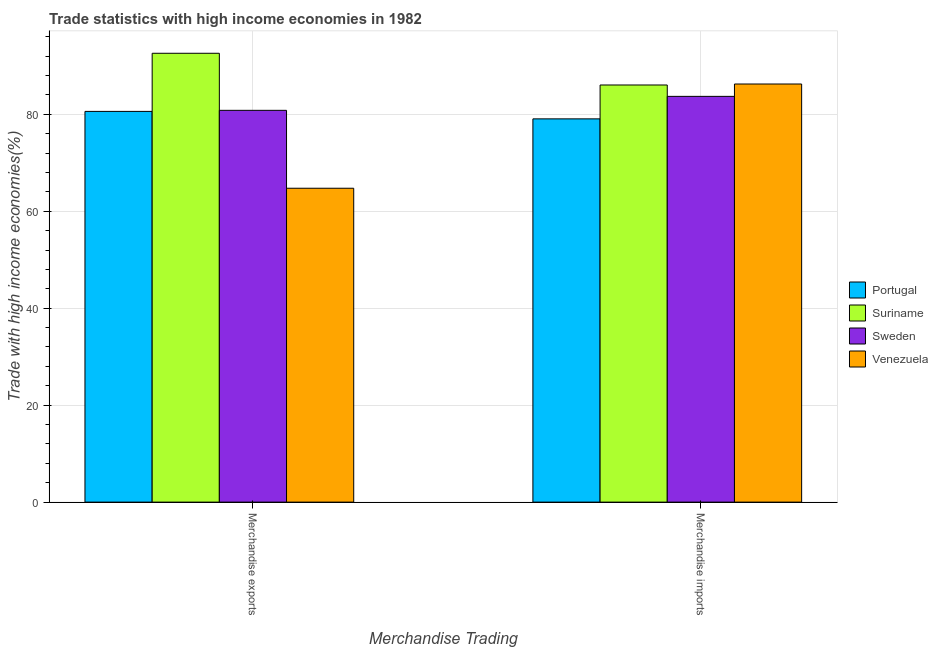How many different coloured bars are there?
Offer a very short reply. 4. How many groups of bars are there?
Keep it short and to the point. 2. How many bars are there on the 1st tick from the left?
Your response must be concise. 4. What is the merchandise imports in Venezuela?
Offer a very short reply. 86.25. Across all countries, what is the maximum merchandise exports?
Your response must be concise. 92.59. Across all countries, what is the minimum merchandise exports?
Your answer should be compact. 64.75. In which country was the merchandise imports maximum?
Your response must be concise. Venezuela. In which country was the merchandise exports minimum?
Keep it short and to the point. Venezuela. What is the total merchandise exports in the graph?
Give a very brief answer. 318.75. What is the difference between the merchandise exports in Portugal and that in Suriname?
Ensure brevity in your answer.  -11.99. What is the difference between the merchandise exports in Venezuela and the merchandise imports in Portugal?
Provide a short and direct response. -14.31. What is the average merchandise imports per country?
Your answer should be very brief. 83.76. What is the difference between the merchandise imports and merchandise exports in Portugal?
Offer a terse response. -1.54. In how many countries, is the merchandise exports greater than 60 %?
Keep it short and to the point. 4. What is the ratio of the merchandise imports in Venezuela to that in Portugal?
Keep it short and to the point. 1.09. In how many countries, is the merchandise imports greater than the average merchandise imports taken over all countries?
Give a very brief answer. 2. What does the 4th bar from the left in Merchandise imports represents?
Offer a terse response. Venezuela. What does the 3rd bar from the right in Merchandise imports represents?
Keep it short and to the point. Suriname. How many bars are there?
Offer a very short reply. 8. How many countries are there in the graph?
Provide a succinct answer. 4. What is the difference between two consecutive major ticks on the Y-axis?
Provide a short and direct response. 20. How many legend labels are there?
Provide a succinct answer. 4. How are the legend labels stacked?
Provide a short and direct response. Vertical. What is the title of the graph?
Give a very brief answer. Trade statistics with high income economies in 1982. What is the label or title of the X-axis?
Provide a succinct answer. Merchandise Trading. What is the label or title of the Y-axis?
Your answer should be very brief. Trade with high income economies(%). What is the Trade with high income economies(%) in Portugal in Merchandise exports?
Your answer should be compact. 80.6. What is the Trade with high income economies(%) of Suriname in Merchandise exports?
Your response must be concise. 92.59. What is the Trade with high income economies(%) of Sweden in Merchandise exports?
Your answer should be very brief. 80.82. What is the Trade with high income economies(%) of Venezuela in Merchandise exports?
Your answer should be very brief. 64.75. What is the Trade with high income economies(%) in Portugal in Merchandise imports?
Offer a very short reply. 79.06. What is the Trade with high income economies(%) in Suriname in Merchandise imports?
Offer a terse response. 86.05. What is the Trade with high income economies(%) of Sweden in Merchandise imports?
Provide a succinct answer. 83.7. What is the Trade with high income economies(%) in Venezuela in Merchandise imports?
Provide a short and direct response. 86.25. Across all Merchandise Trading, what is the maximum Trade with high income economies(%) in Portugal?
Give a very brief answer. 80.6. Across all Merchandise Trading, what is the maximum Trade with high income economies(%) of Suriname?
Give a very brief answer. 92.59. Across all Merchandise Trading, what is the maximum Trade with high income economies(%) of Sweden?
Give a very brief answer. 83.7. Across all Merchandise Trading, what is the maximum Trade with high income economies(%) of Venezuela?
Your response must be concise. 86.25. Across all Merchandise Trading, what is the minimum Trade with high income economies(%) of Portugal?
Provide a short and direct response. 79.06. Across all Merchandise Trading, what is the minimum Trade with high income economies(%) of Suriname?
Give a very brief answer. 86.05. Across all Merchandise Trading, what is the minimum Trade with high income economies(%) in Sweden?
Provide a succinct answer. 80.82. Across all Merchandise Trading, what is the minimum Trade with high income economies(%) in Venezuela?
Provide a succinct answer. 64.75. What is the total Trade with high income economies(%) in Portugal in the graph?
Provide a succinct answer. 159.66. What is the total Trade with high income economies(%) of Suriname in the graph?
Offer a very short reply. 178.64. What is the total Trade with high income economies(%) in Sweden in the graph?
Provide a succinct answer. 164.52. What is the total Trade with high income economies(%) in Venezuela in the graph?
Offer a terse response. 151. What is the difference between the Trade with high income economies(%) in Portugal in Merchandise exports and that in Merchandise imports?
Your response must be concise. 1.54. What is the difference between the Trade with high income economies(%) of Suriname in Merchandise exports and that in Merchandise imports?
Provide a succinct answer. 6.54. What is the difference between the Trade with high income economies(%) of Sweden in Merchandise exports and that in Merchandise imports?
Make the answer very short. -2.88. What is the difference between the Trade with high income economies(%) of Venezuela in Merchandise exports and that in Merchandise imports?
Ensure brevity in your answer.  -21.5. What is the difference between the Trade with high income economies(%) of Portugal in Merchandise exports and the Trade with high income economies(%) of Suriname in Merchandise imports?
Your answer should be very brief. -5.45. What is the difference between the Trade with high income economies(%) in Portugal in Merchandise exports and the Trade with high income economies(%) in Sweden in Merchandise imports?
Offer a terse response. -3.1. What is the difference between the Trade with high income economies(%) of Portugal in Merchandise exports and the Trade with high income economies(%) of Venezuela in Merchandise imports?
Offer a terse response. -5.65. What is the difference between the Trade with high income economies(%) in Suriname in Merchandise exports and the Trade with high income economies(%) in Sweden in Merchandise imports?
Your response must be concise. 8.89. What is the difference between the Trade with high income economies(%) in Suriname in Merchandise exports and the Trade with high income economies(%) in Venezuela in Merchandise imports?
Provide a succinct answer. 6.34. What is the difference between the Trade with high income economies(%) of Sweden in Merchandise exports and the Trade with high income economies(%) of Venezuela in Merchandise imports?
Your response must be concise. -5.43. What is the average Trade with high income economies(%) of Portugal per Merchandise Trading?
Make the answer very short. 79.83. What is the average Trade with high income economies(%) in Suriname per Merchandise Trading?
Offer a terse response. 89.32. What is the average Trade with high income economies(%) of Sweden per Merchandise Trading?
Your answer should be compact. 82.26. What is the average Trade with high income economies(%) in Venezuela per Merchandise Trading?
Your answer should be very brief. 75.5. What is the difference between the Trade with high income economies(%) in Portugal and Trade with high income economies(%) in Suriname in Merchandise exports?
Your answer should be compact. -11.99. What is the difference between the Trade with high income economies(%) of Portugal and Trade with high income economies(%) of Sweden in Merchandise exports?
Offer a very short reply. -0.22. What is the difference between the Trade with high income economies(%) in Portugal and Trade with high income economies(%) in Venezuela in Merchandise exports?
Keep it short and to the point. 15.85. What is the difference between the Trade with high income economies(%) in Suriname and Trade with high income economies(%) in Sweden in Merchandise exports?
Your answer should be compact. 11.77. What is the difference between the Trade with high income economies(%) in Suriname and Trade with high income economies(%) in Venezuela in Merchandise exports?
Your answer should be very brief. 27.84. What is the difference between the Trade with high income economies(%) in Sweden and Trade with high income economies(%) in Venezuela in Merchandise exports?
Offer a terse response. 16.07. What is the difference between the Trade with high income economies(%) in Portugal and Trade with high income economies(%) in Suriname in Merchandise imports?
Offer a very short reply. -6.99. What is the difference between the Trade with high income economies(%) in Portugal and Trade with high income economies(%) in Sweden in Merchandise imports?
Make the answer very short. -4.64. What is the difference between the Trade with high income economies(%) of Portugal and Trade with high income economies(%) of Venezuela in Merchandise imports?
Your answer should be compact. -7.19. What is the difference between the Trade with high income economies(%) of Suriname and Trade with high income economies(%) of Sweden in Merchandise imports?
Provide a short and direct response. 2.35. What is the difference between the Trade with high income economies(%) in Suriname and Trade with high income economies(%) in Venezuela in Merchandise imports?
Provide a succinct answer. -0.2. What is the difference between the Trade with high income economies(%) of Sweden and Trade with high income economies(%) of Venezuela in Merchandise imports?
Your answer should be very brief. -2.55. What is the ratio of the Trade with high income economies(%) in Portugal in Merchandise exports to that in Merchandise imports?
Offer a terse response. 1.02. What is the ratio of the Trade with high income economies(%) of Suriname in Merchandise exports to that in Merchandise imports?
Make the answer very short. 1.08. What is the ratio of the Trade with high income economies(%) of Sweden in Merchandise exports to that in Merchandise imports?
Your answer should be very brief. 0.97. What is the ratio of the Trade with high income economies(%) of Venezuela in Merchandise exports to that in Merchandise imports?
Provide a short and direct response. 0.75. What is the difference between the highest and the second highest Trade with high income economies(%) of Portugal?
Provide a short and direct response. 1.54. What is the difference between the highest and the second highest Trade with high income economies(%) of Suriname?
Offer a very short reply. 6.54. What is the difference between the highest and the second highest Trade with high income economies(%) of Sweden?
Your answer should be very brief. 2.88. What is the difference between the highest and the second highest Trade with high income economies(%) of Venezuela?
Offer a very short reply. 21.5. What is the difference between the highest and the lowest Trade with high income economies(%) in Portugal?
Make the answer very short. 1.54. What is the difference between the highest and the lowest Trade with high income economies(%) of Suriname?
Keep it short and to the point. 6.54. What is the difference between the highest and the lowest Trade with high income economies(%) in Sweden?
Your response must be concise. 2.88. What is the difference between the highest and the lowest Trade with high income economies(%) of Venezuela?
Keep it short and to the point. 21.5. 